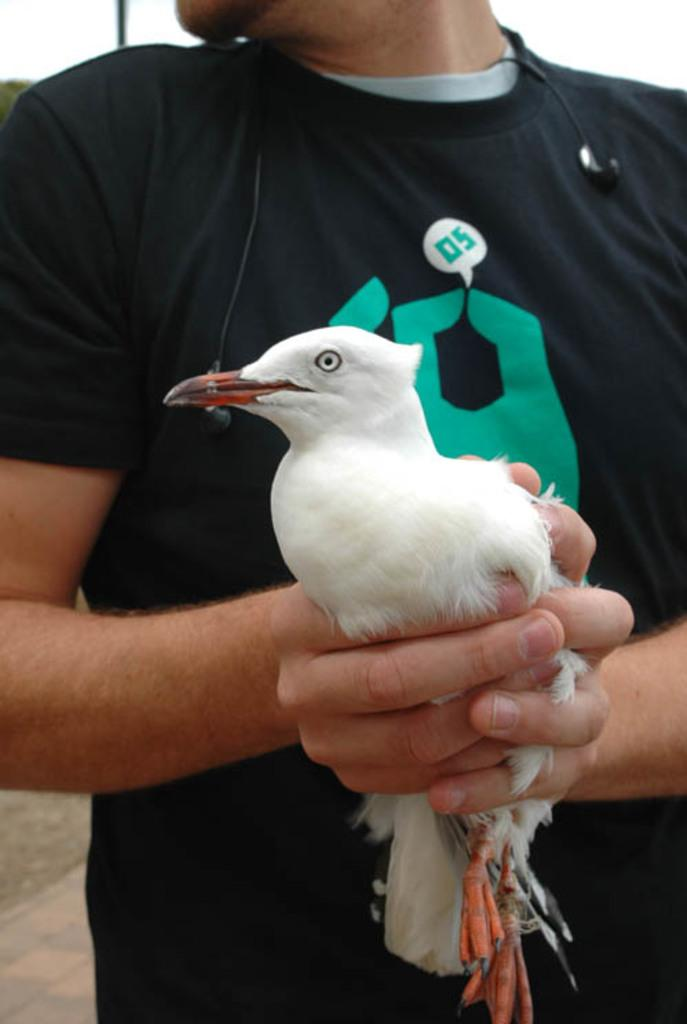Who is the main subject in the image? There is a man in the image. What is the man doing in the image? The man is holding a bird with his hands. What type of surface can be seen in the background of the image? There is ground visible in the background of the image. What part of the natural environment is visible in the image? The sky is visible in the background of the image. What type of stocking is the man wearing on his brother's apparel in the image? There is no mention of stockings, a brother, or apparel in the image; the man is simply holding a bird. 